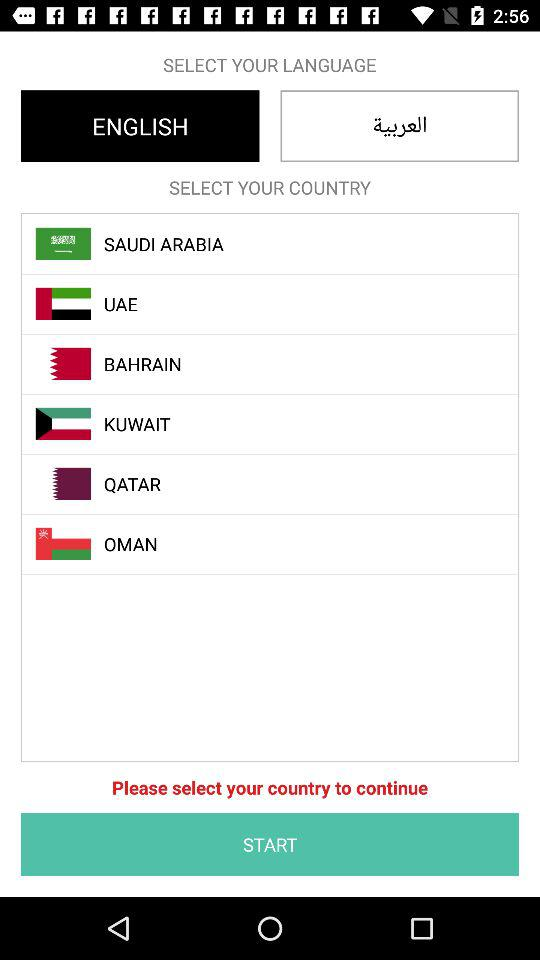Which language is selected? The selected language is English. 